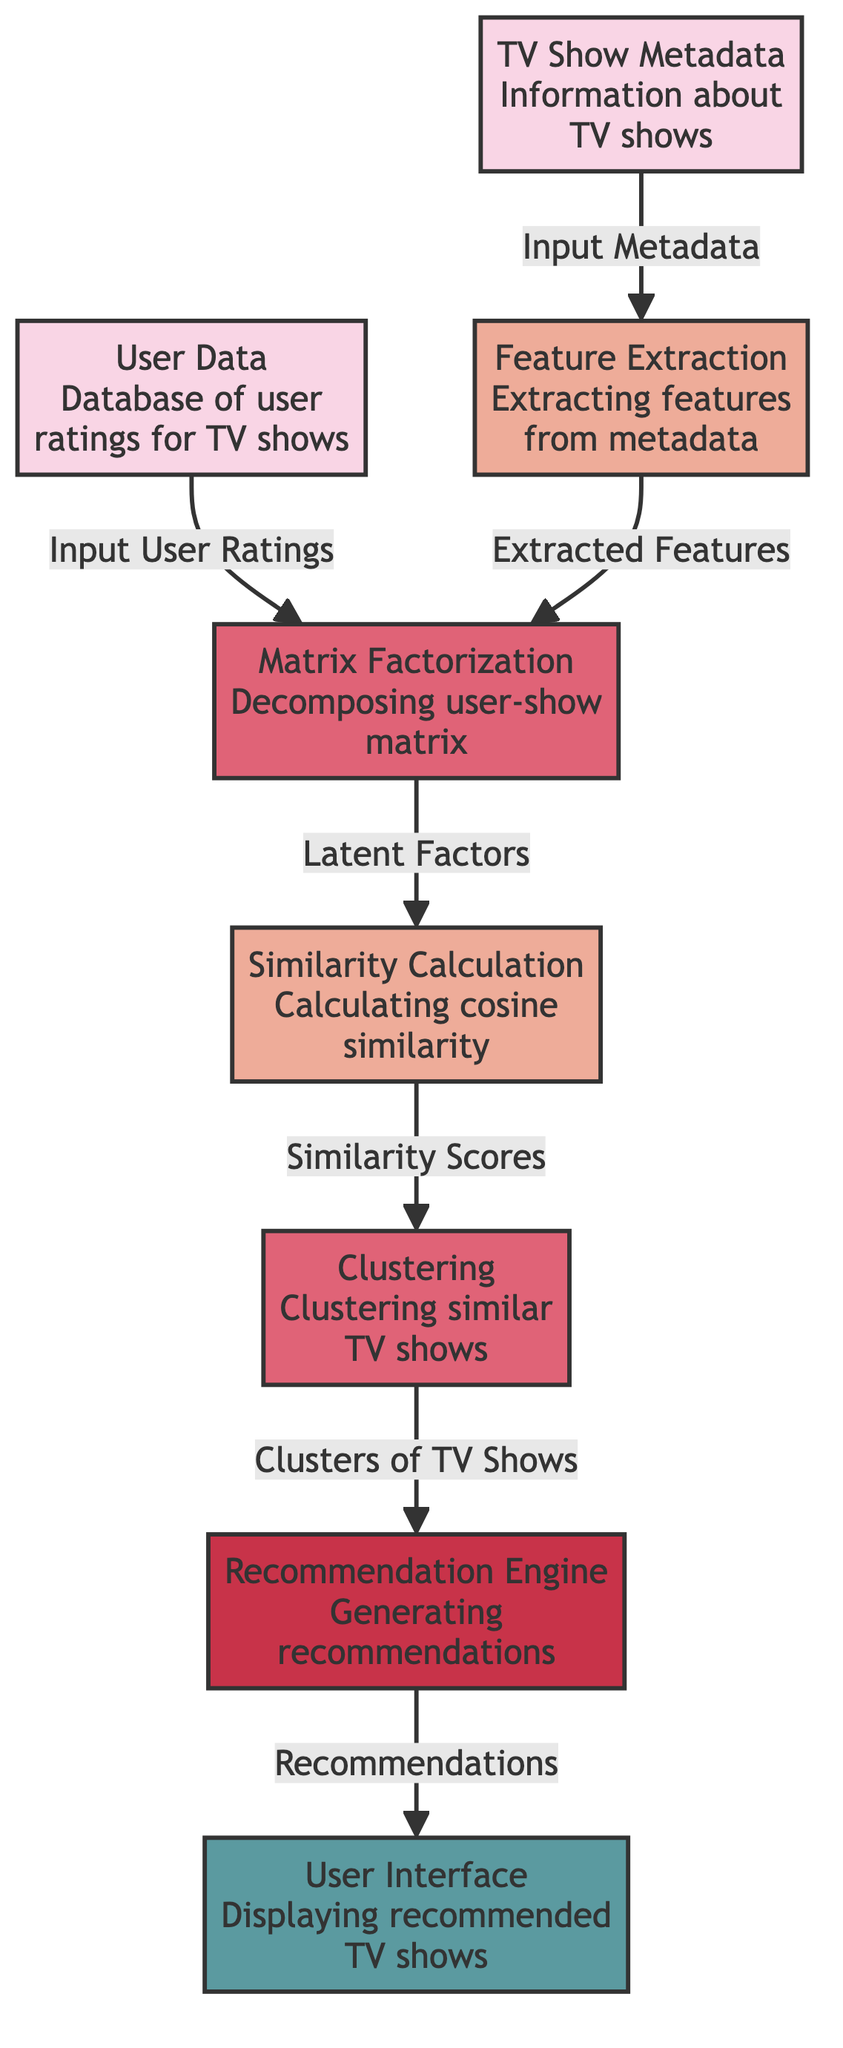What is the first node in the diagram? The first node in the diagram is "User Data Database of user ratings for TV shows". It is positioned at the top and serves as the initial input source for the recommendation process.
Answer: User Data Database of user ratings for TV shows How many nodes are there in the diagram? By counting the nodes in the diagram, we find there are a total of eight distinct nodes, ranging from input data to recommendation output.
Answer: 8 What type of process extracts features in this diagram? The process that extracts features in this diagram is labeled "Feature Extraction". This node represents a critical step in processing the TV show metadata for further analysis.
Answer: Feature Extraction What does the "Matrix Factorization" node produce? The "Matrix Factorization" node produces "Latent Factors", which are essential for understanding the underlying relationships between users and TV shows in the recommendation process.
Answer: Latent Factors What is the last output of the diagram? The last output of the diagram is "Displaying recommended TV shows". This indicates the final step where the user interacts with the recommendations generated by the engine.
Answer: Displaying recommended TV shows Which node receives "Extracted Features" as input? The node that receives "Extracted Features" as input is "Matrix Factorization". This indicates that the extracted features are necessary for decomposing the user-show matrix into latent factors.
Answer: Matrix Factorization What is the connection between "Similarity Calculation" and "Clustering"? The connection is that "Similarity Calculation" generates "Similarity Scores", which are utilized as input for the "Clustering" process. This shows the flow of information from one analysis stage to another.
Answer: Similarity Scores How does the recommendation engine generate recommendations? The recommendation engine generates recommendations by taking input from the "Clusters of TV Shows" produced by the clustering process, allowing it to suggest specific TV shows that are similar to "Wynonna Earp".
Answer: Clusters of TV Shows 